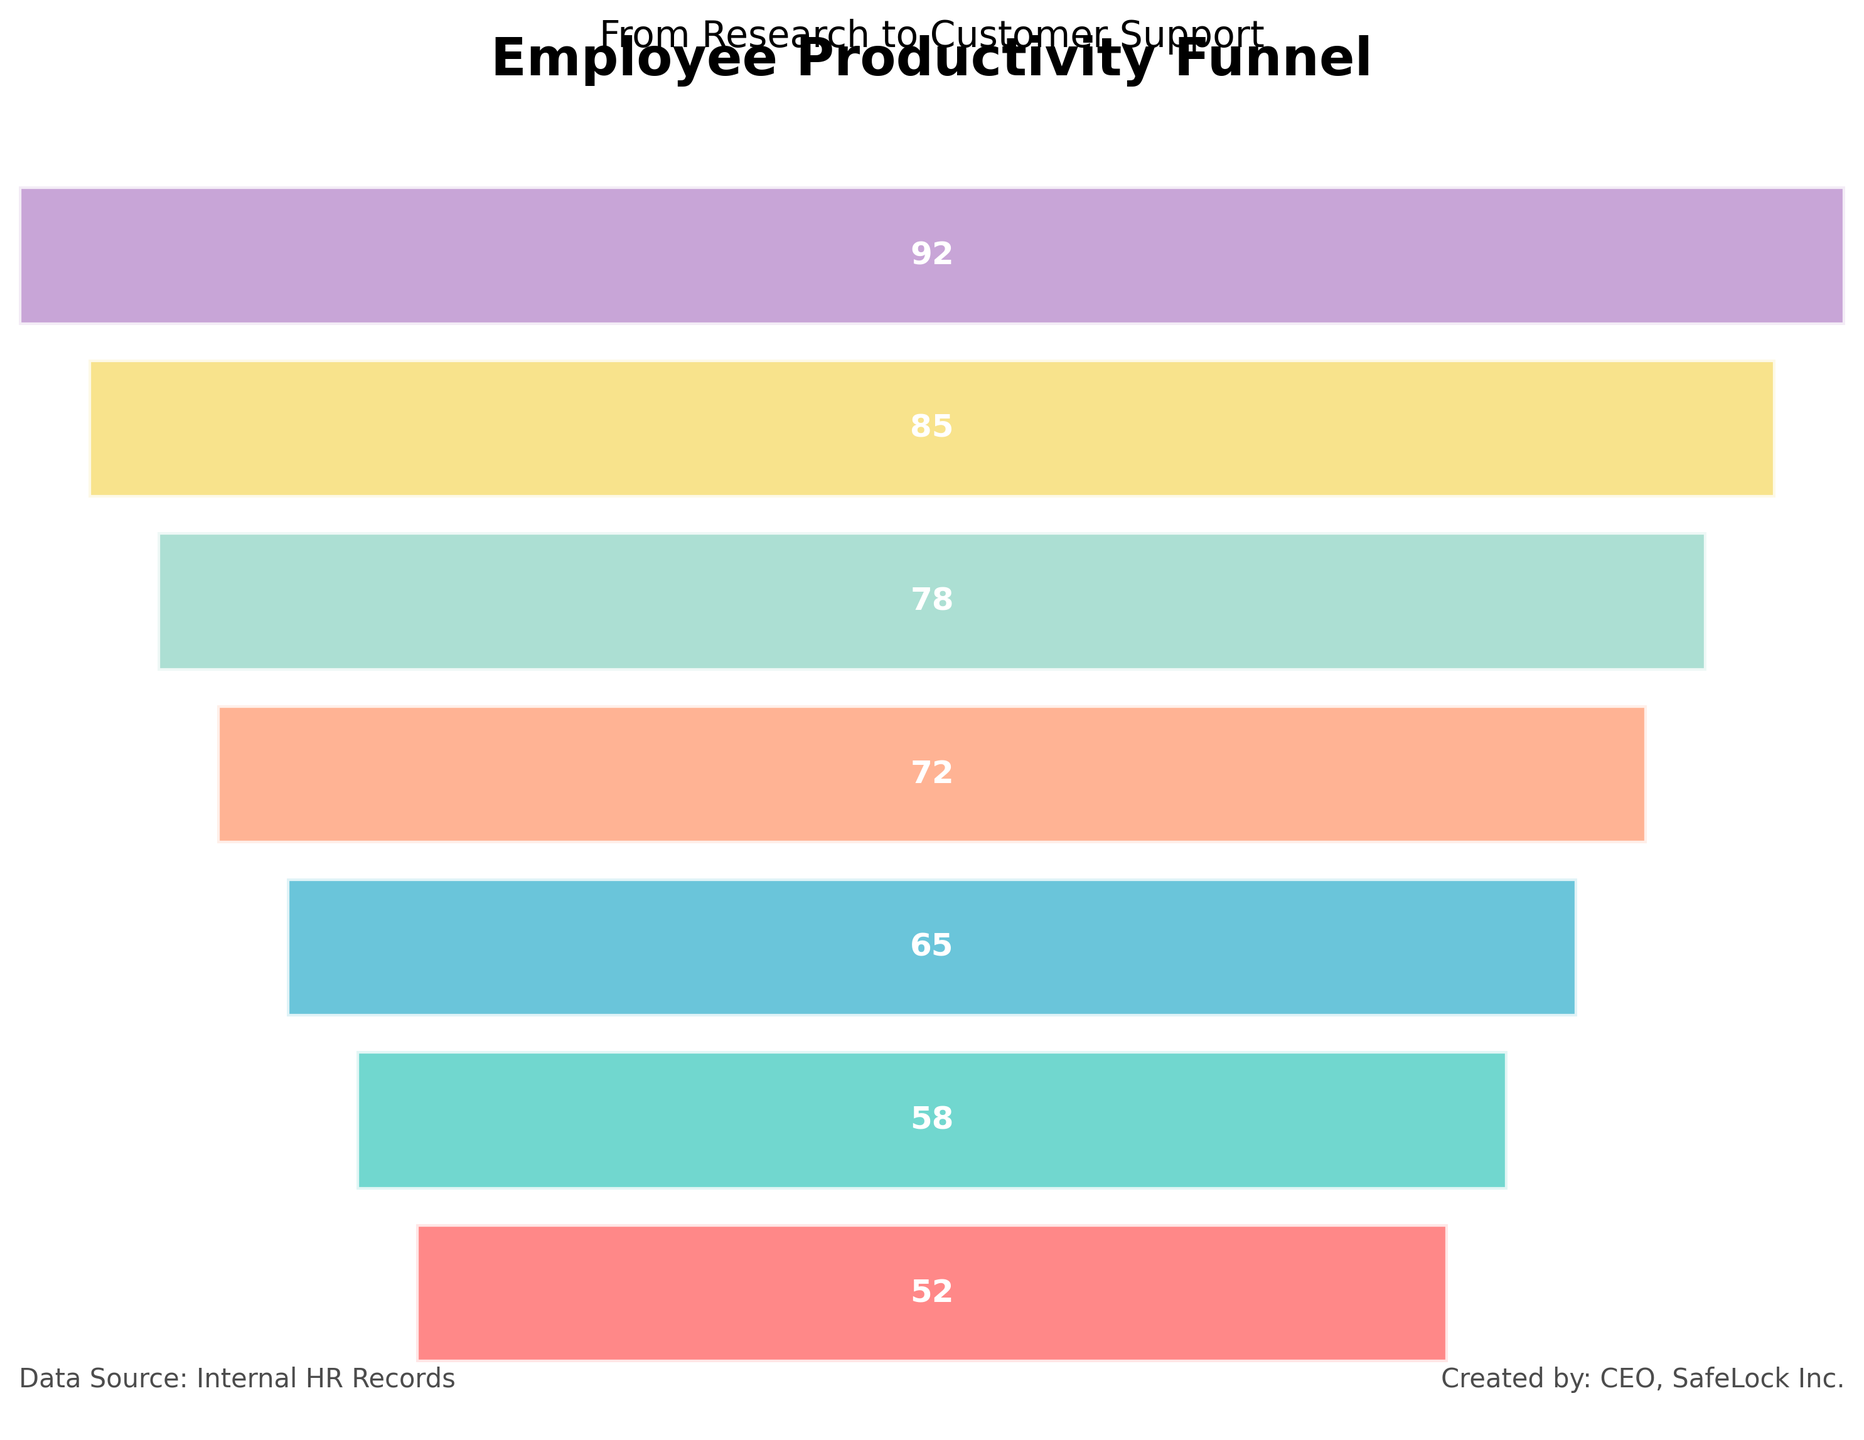What is the title of the figure? The title of a figure is usually placed at the top and is meant to provide an overview of what the figure is about. In this case, the title is "Employee Productivity Funnel," which is clearly displayed in a large, bold font at the top of the chart.
Answer: Employee Productivity Funnel How many departments are represented in the figure? The number of departments is countable from the bars listed on the y-axis. Each bar corresponds to a different department. By counting the bars, we can determine the number of departments. The chart shows bars for 7 different departments.
Answer: 7 Which department has the highest productivity score? The department with the highest productivity score will have the widest bar at the top of the funnel chart because the data is reversed for a bottom-up funnel. The top bar representing "Research and Development" is the widest, indicating the highest score.
Answer: Research and Development What is the productivity score for Quality Control? The productivity score for a specific department can be found by looking at the label within the corresponding bar. The Quality Control department’s bar shows a score of 72, which is the number displayed within the bar.
Answer: 72 Which department has the lowest productivity score? In a funnel chart, the department with the lowest score will have the narrowest bar at the bottom. By observing the chart, the Sales department has the lowest productivity score with the narrowest bar at the bottom of the funnel.
Answer: Customer Support What is the difference in productivity score between Marketing and Sales? To find the difference, identify the productivity scores for Marketing and Sales from the bars, which are 65 and 58, respectively. Subtract the lower score from the higher one: 65 - 58 = 7.
Answer: 7 What is the average productivity score of Manufacturing and Product Design departments? To find the average, add the productivity scores of Manufacturing (78) and Product Design (85), then divide by 2. The calculation is (78 + 85) / 2 = 81.5.
Answer: 81.5 How does the productivity score of Research and Development compare to that of Customer Support? Compare the scores by noting the values for both departments. Research and Development has a score of 92, and Customer Support has a score of 52. Thus, Research and Development’s score is significantly higher.
Answer: Higher What could be a potential reason for the gradual decrease in productivity scores from Research and Development to Customer Support? Observing the trend in the chart, where each successive department has a lower productivity score, it could suggest a bottleneck effect, workload distribution imbalance, or differences in department-specific challenges. This is an interpretative question and may not have one definitive answer based on the visual information alone.
Answer: Various operational and structural factors What color represents the Manufacturing department in this chart? The chart uses different colors for each department’s bar. The Manufacturing department's bar is identified by seeking its position and color in the funnel. The chart shows Manufacturing in a medium blue color (#45B7D1).
Answer: Medium Blue 